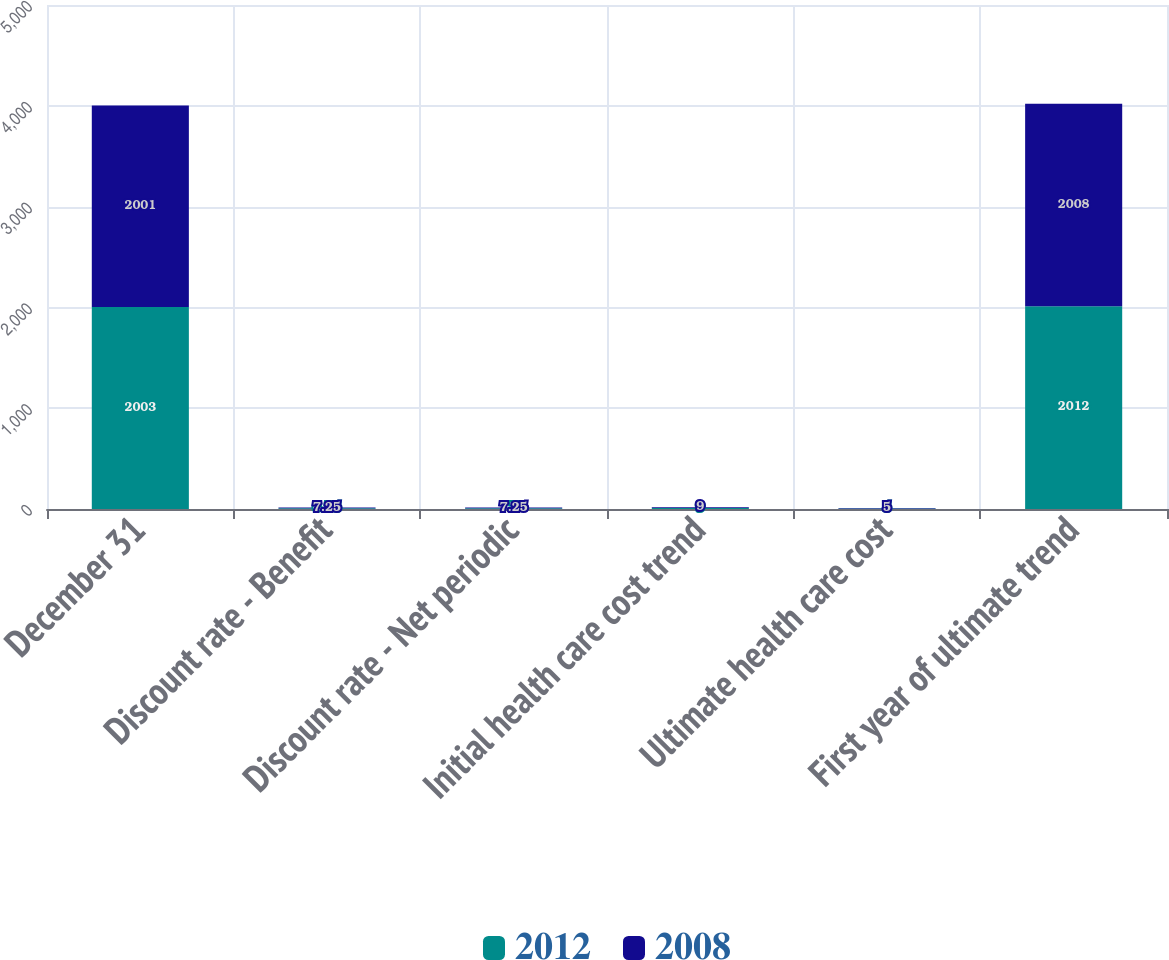Convert chart. <chart><loc_0><loc_0><loc_500><loc_500><stacked_bar_chart><ecel><fcel>December 31<fcel>Discount rate - Benefit<fcel>Discount rate - Net periodic<fcel>Initial health care cost trend<fcel>Ultimate health care cost<fcel>First year of ultimate trend<nl><fcel>2012<fcel>2003<fcel>6.75<fcel>7<fcel>9<fcel>5<fcel>2012<nl><fcel>2008<fcel>2001<fcel>7.25<fcel>7.25<fcel>9<fcel>5<fcel>2008<nl></chart> 